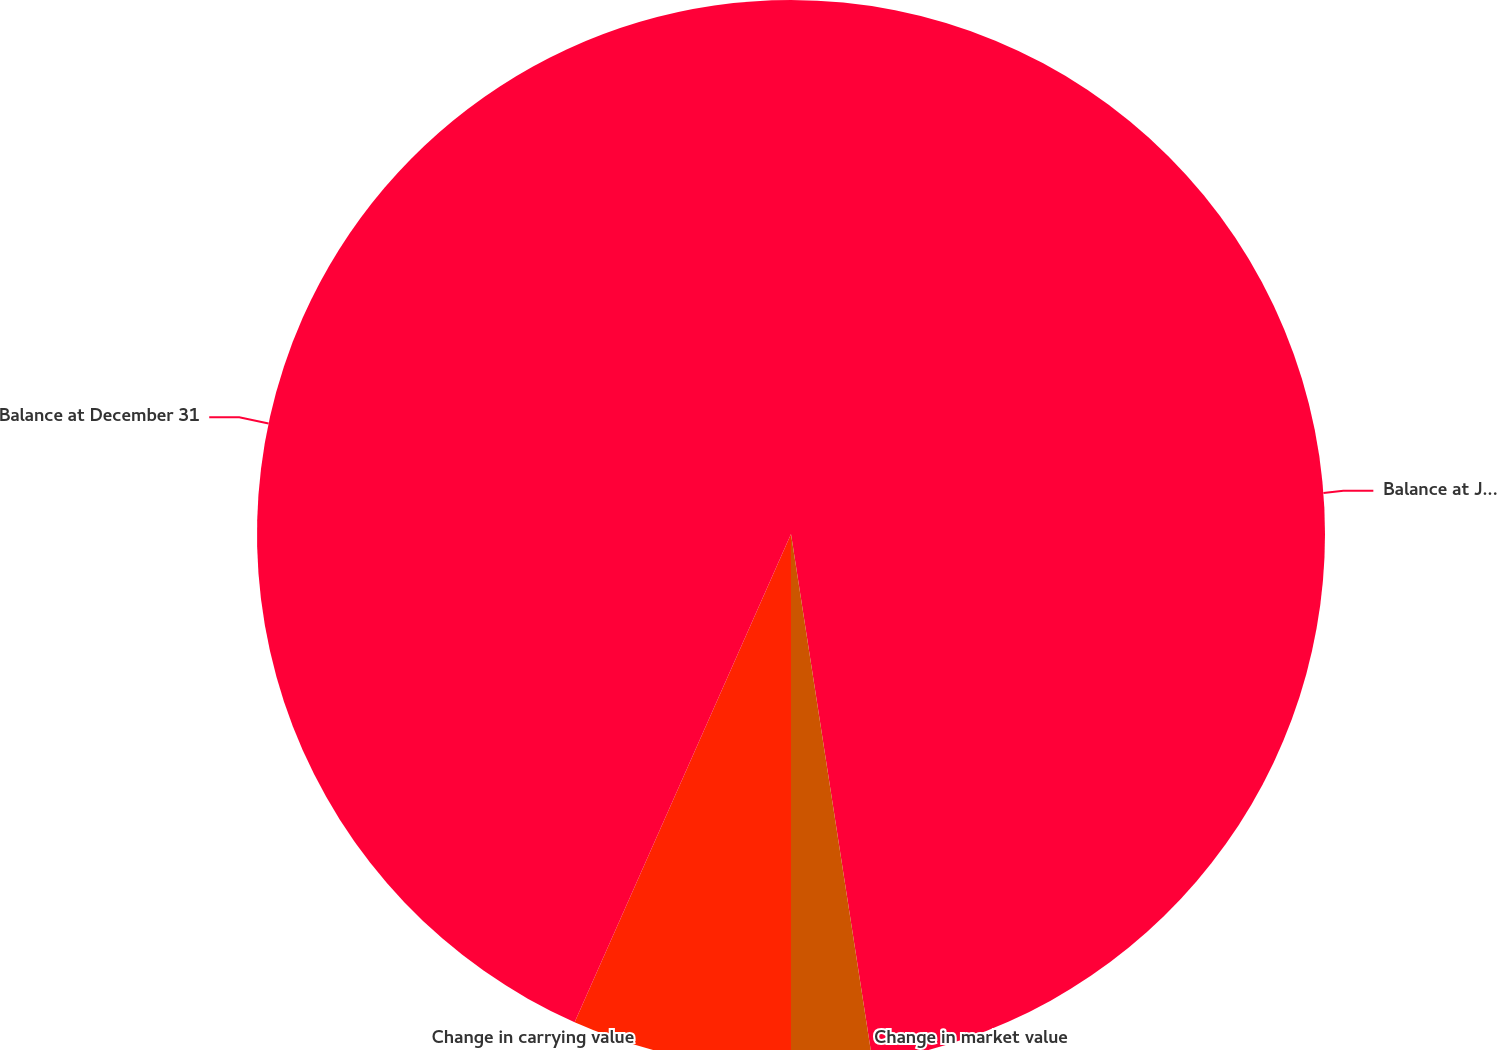Convert chart. <chart><loc_0><loc_0><loc_500><loc_500><pie_chart><fcel>Balance at January 1<fcel>Change in market value<fcel>Change in carrying value<fcel>Balance at December 31<nl><fcel>47.56%<fcel>2.44%<fcel>6.64%<fcel>43.36%<nl></chart> 